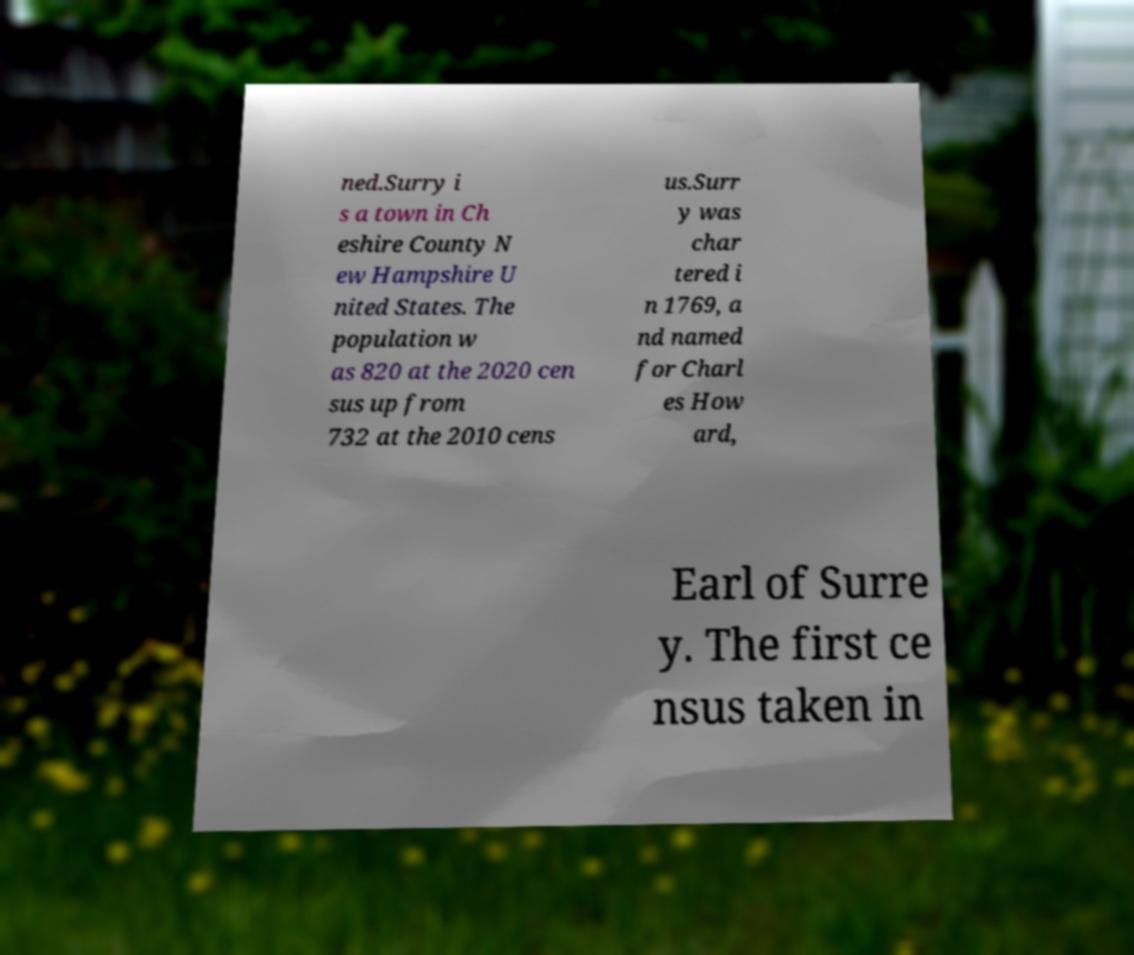I need the written content from this picture converted into text. Can you do that? ned.Surry i s a town in Ch eshire County N ew Hampshire U nited States. The population w as 820 at the 2020 cen sus up from 732 at the 2010 cens us.Surr y was char tered i n 1769, a nd named for Charl es How ard, Earl of Surre y. The first ce nsus taken in 